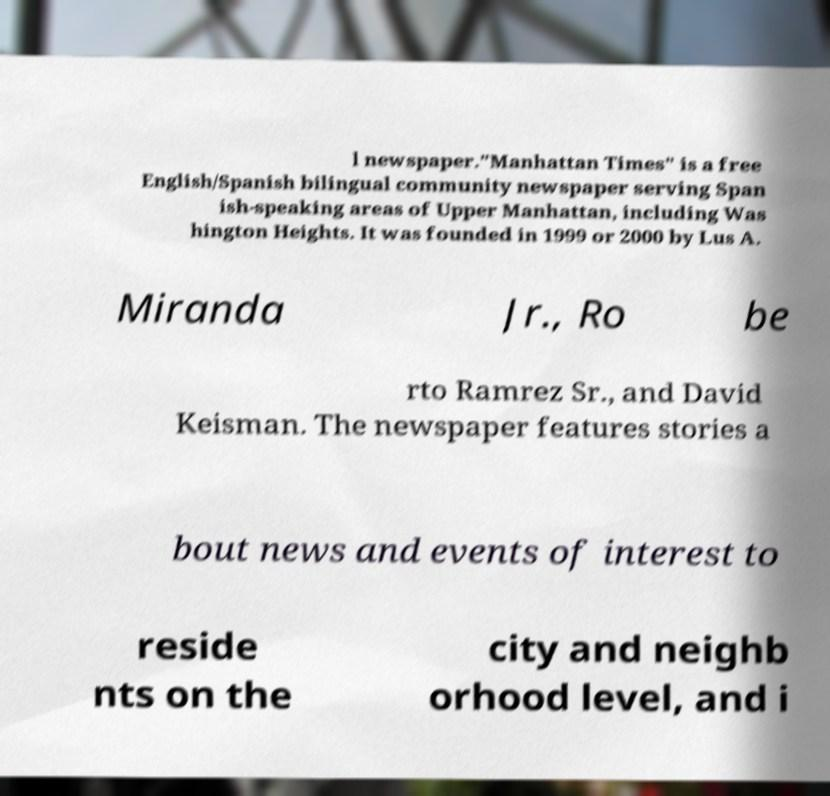Could you extract and type out the text from this image? l newspaper."Manhattan Times" is a free English/Spanish bilingual community newspaper serving Span ish-speaking areas of Upper Manhattan, including Was hington Heights. It was founded in 1999 or 2000 by Lus A. Miranda Jr., Ro be rto Ramrez Sr., and David Keisman. The newspaper features stories a bout news and events of interest to reside nts on the city and neighb orhood level, and i 